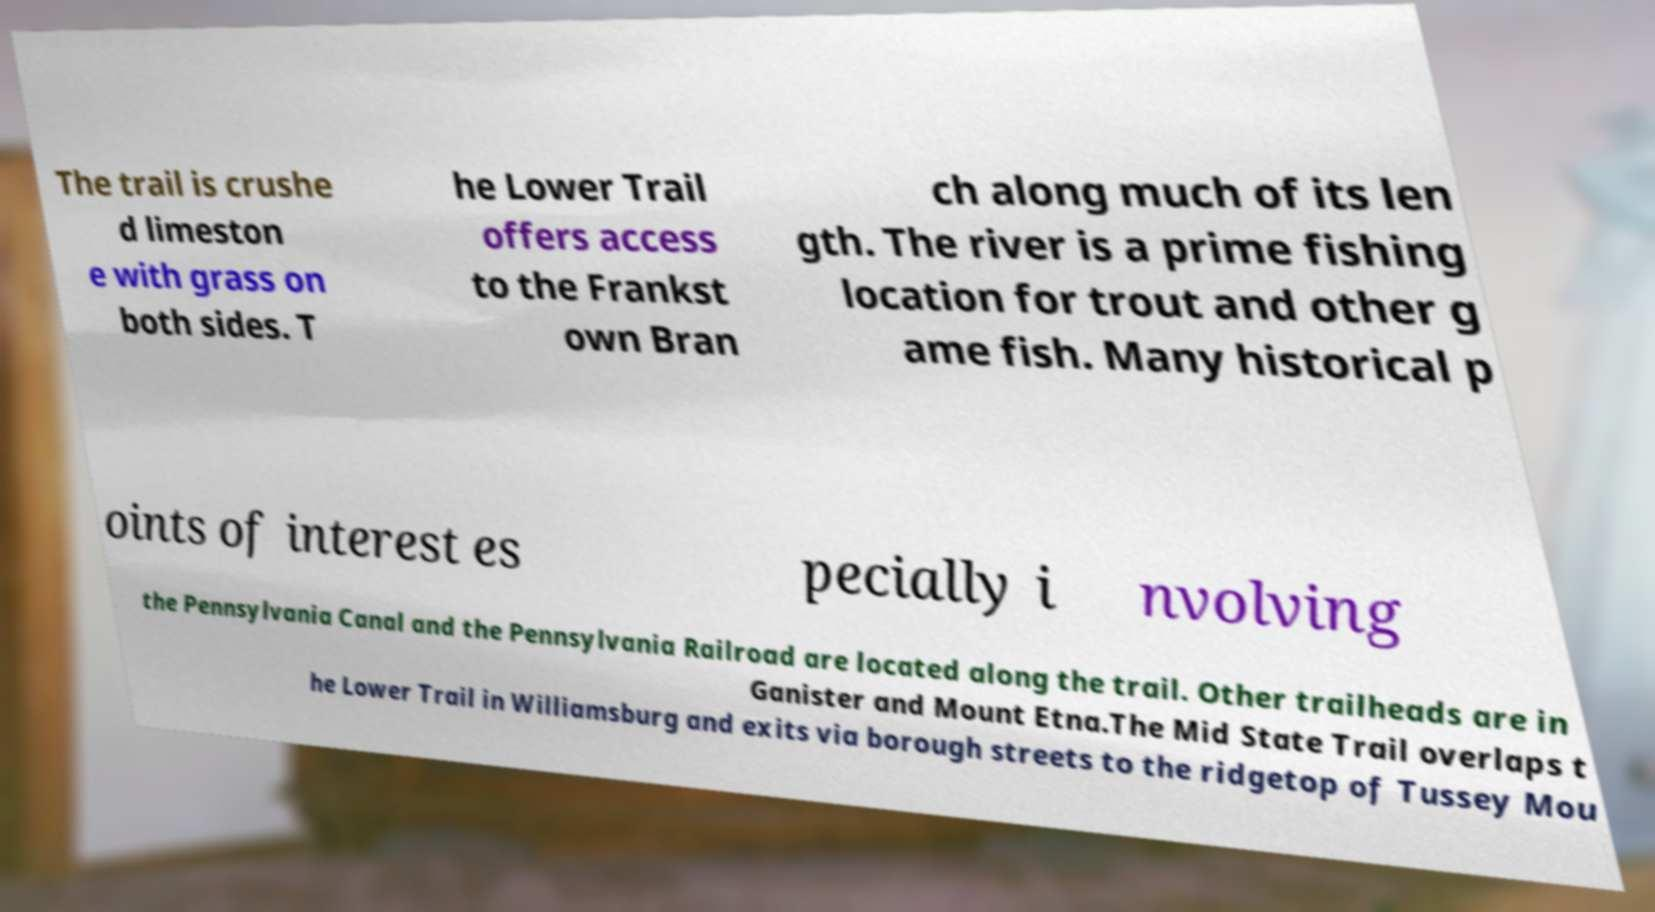Please identify and transcribe the text found in this image. The trail is crushe d limeston e with grass on both sides. T he Lower Trail offers access to the Frankst own Bran ch along much of its len gth. The river is a prime fishing location for trout and other g ame fish. Many historical p oints of interest es pecially i nvolving the Pennsylvania Canal and the Pennsylvania Railroad are located along the trail. Other trailheads are in Ganister and Mount Etna.The Mid State Trail overlaps t he Lower Trail in Williamsburg and exits via borough streets to the ridgetop of Tussey Mou 